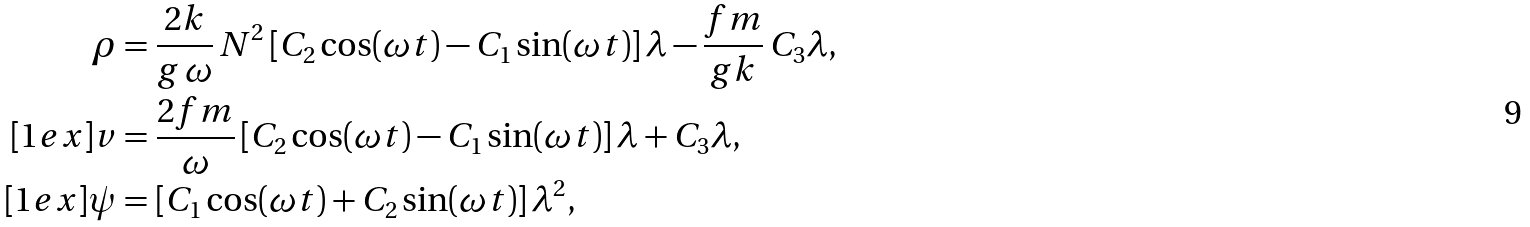Convert formula to latex. <formula><loc_0><loc_0><loc_500><loc_500>\rho & = \frac { 2 k } { g \, \omega } \, N ^ { 2 } \left [ C _ { 2 } \cos ( \omega t ) - C _ { 1 } \sin ( \omega t ) \right ] \lambda - \frac { f m } { g k } \, C _ { 3 } \lambda , \\ [ 1 e x ] v & = \frac { 2 f m } { \omega } \left [ C _ { 2 } \cos ( \omega t ) - C _ { 1 } \sin ( \omega t ) \right ] \lambda + C _ { 3 } \lambda , \\ [ 1 e x ] \psi & = \left [ C _ { 1 } \cos ( \omega t ) + C _ { 2 } \sin ( \omega t ) \right ] \lambda ^ { 2 } ,</formula> 